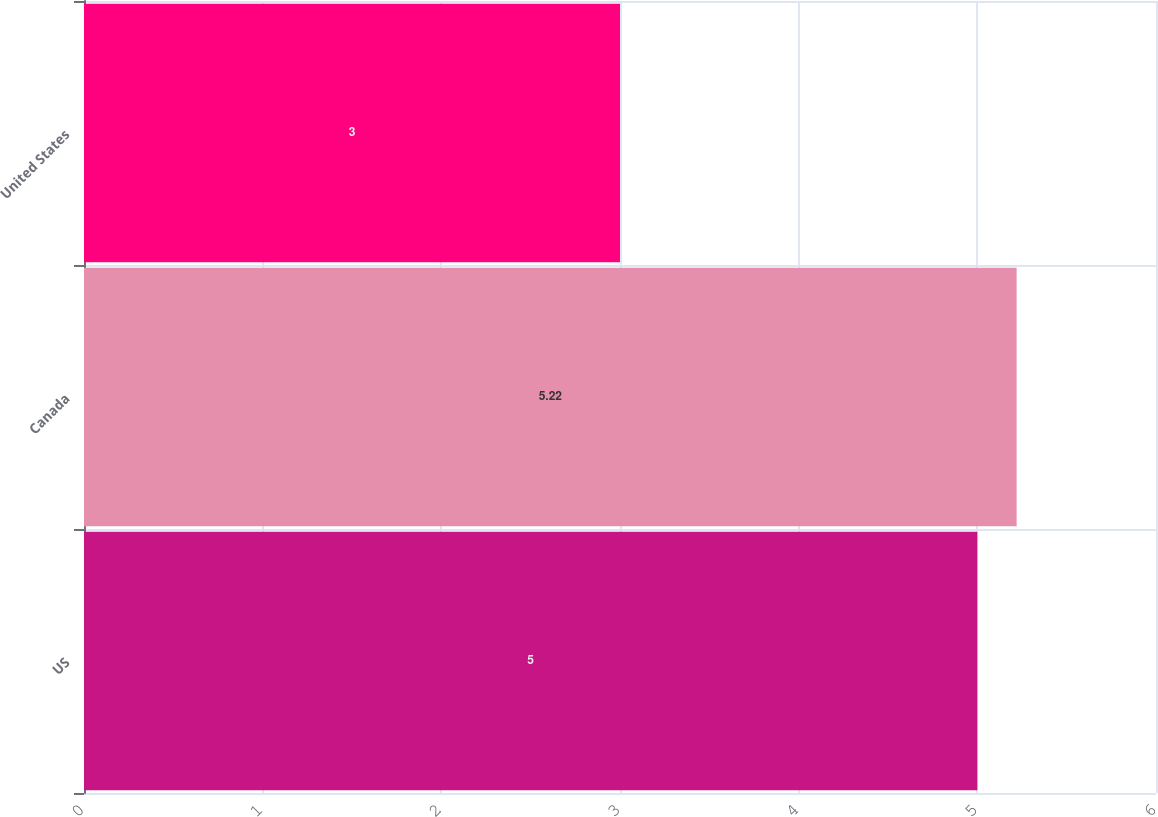<chart> <loc_0><loc_0><loc_500><loc_500><bar_chart><fcel>US<fcel>Canada<fcel>United States<nl><fcel>5<fcel>5.22<fcel>3<nl></chart> 